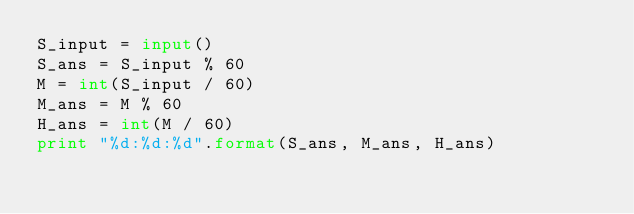Convert code to text. <code><loc_0><loc_0><loc_500><loc_500><_Python_>S_input = input()
S_ans = S_input % 60
M = int(S_input / 60)
M_ans = M % 60
H_ans = int(M / 60)
print "%d:%d:%d".format(S_ans, M_ans, H_ans)</code> 